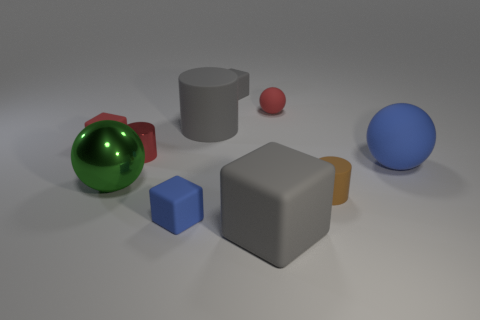What material is the cylinder to the left of the blue matte object that is on the left side of the big gray object that is in front of the blue sphere?
Make the answer very short. Metal. What is the shape of the green object that is made of the same material as the tiny red cylinder?
Offer a terse response. Sphere. There is a metal sphere that is in front of the big matte ball; are there any red rubber objects to the left of it?
Your response must be concise. Yes. How big is the gray cylinder?
Your response must be concise. Large. What number of objects are big gray objects or small gray metal balls?
Provide a succinct answer. 2. Does the blue thing right of the tiny brown rubber cylinder have the same material as the gray block in front of the tiny gray cube?
Ensure brevity in your answer.  Yes. What is the color of the other ball that is the same material as the red ball?
Ensure brevity in your answer.  Blue. What number of red matte things have the same size as the brown matte object?
Give a very brief answer. 2. What number of other things are there of the same color as the small rubber ball?
Provide a succinct answer. 2. Is there anything else that is the same size as the red matte cube?
Your response must be concise. Yes. 